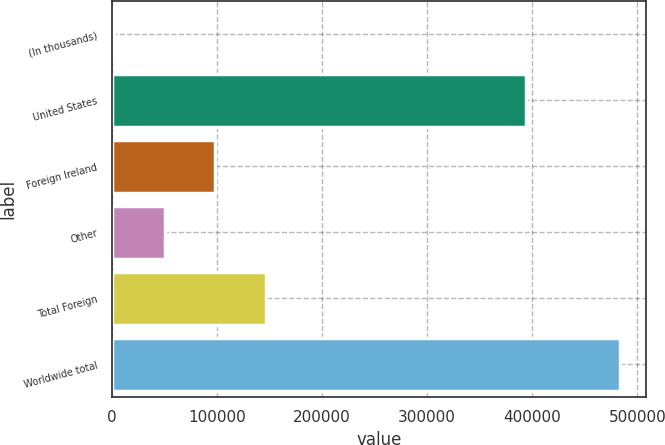Convert chart. <chart><loc_0><loc_0><loc_500><loc_500><bar_chart><fcel>(In thousands)<fcel>United States<fcel>Foreign Ireland<fcel>Other<fcel>Total Foreign<fcel>Worldwide total<nl><fcel>2003<fcel>394544<fcel>98344<fcel>50173.5<fcel>146514<fcel>483708<nl></chart> 